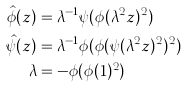Convert formula to latex. <formula><loc_0><loc_0><loc_500><loc_500>\hat { \phi } ( z ) & = \lambda ^ { - 1 } \psi ( \phi ( \lambda ^ { 2 } z ) ^ { 2 } ) \\ \hat { \psi } ( z ) & = \lambda ^ { - 1 } \phi ( \phi ( \psi ( \lambda ^ { 2 } z ) ^ { 2 } ) ^ { 2 } ) \\ \lambda & = - \phi ( \phi ( 1 ) ^ { 2 } )</formula> 